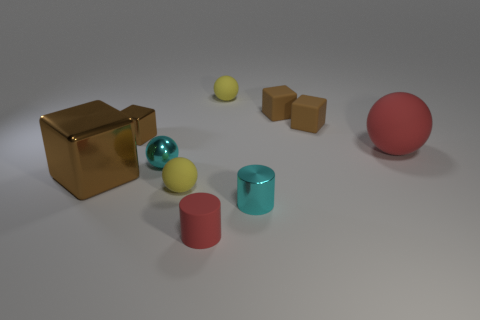Subtract all big cubes. How many cubes are left? 3 Subtract all red cubes. How many yellow balls are left? 2 Subtract all yellow spheres. How many spheres are left? 2 Subtract all cylinders. How many objects are left? 8 Subtract all yellow matte balls. Subtract all small red things. How many objects are left? 7 Add 6 tiny cubes. How many tiny cubes are left? 9 Add 9 large green shiny spheres. How many large green shiny spheres exist? 9 Subtract 0 yellow cylinders. How many objects are left? 10 Subtract all cyan spheres. Subtract all brown cylinders. How many spheres are left? 3 